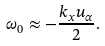<formula> <loc_0><loc_0><loc_500><loc_500>\omega _ { 0 } \approx - \frac { k _ { x } u _ { \alpha } } { 2 } .</formula> 